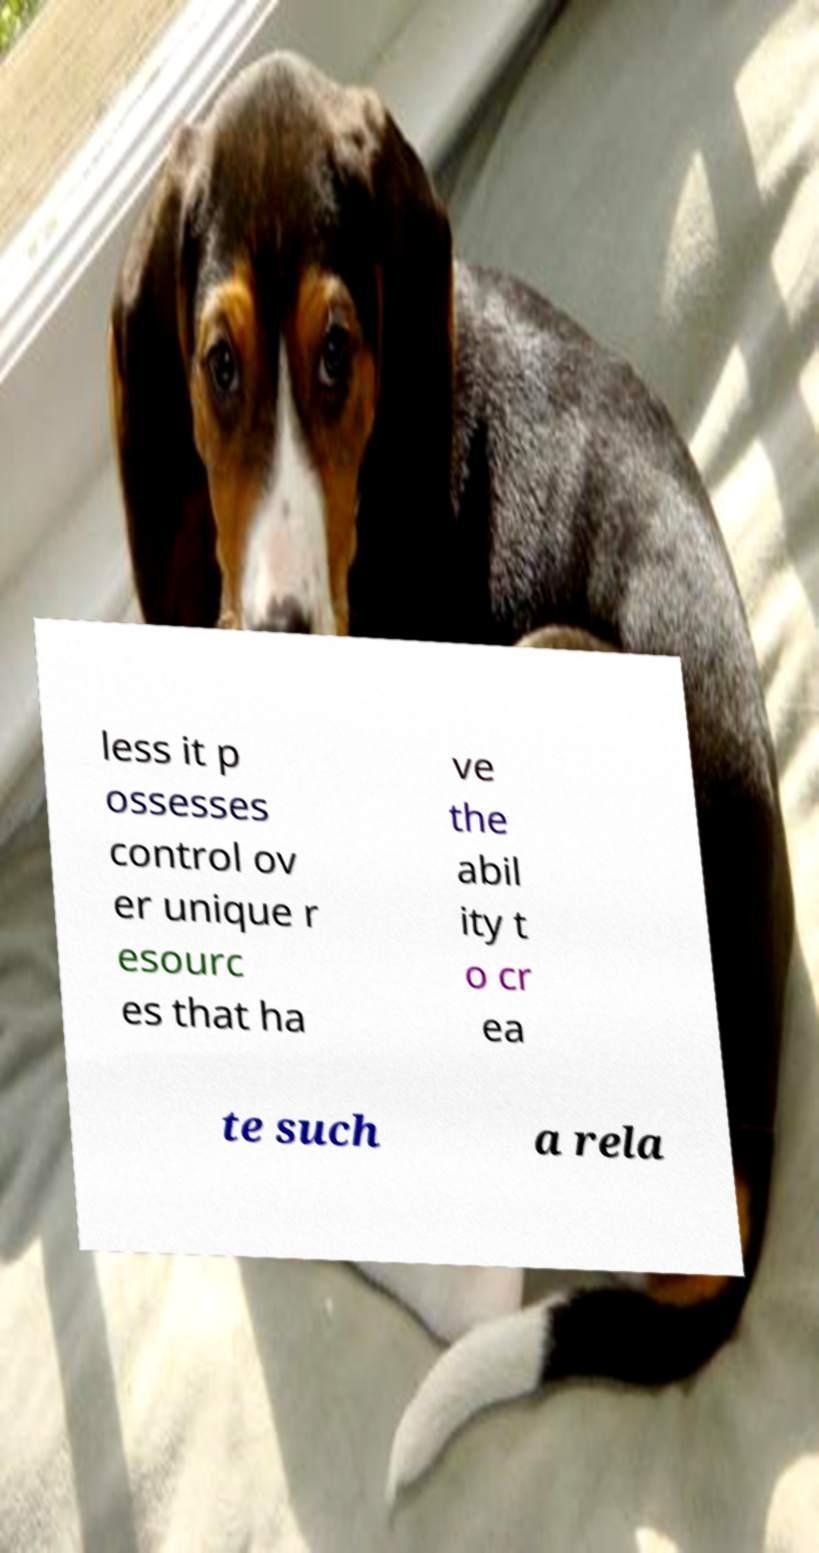Can you read and provide the text displayed in the image?This photo seems to have some interesting text. Can you extract and type it out for me? less it p ossesses control ov er unique r esourc es that ha ve the abil ity t o cr ea te such a rela 